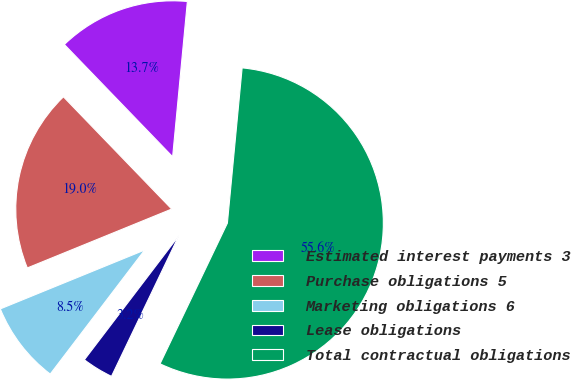Convert chart to OTSL. <chart><loc_0><loc_0><loc_500><loc_500><pie_chart><fcel>Estimated interest payments 3<fcel>Purchase obligations 5<fcel>Marketing obligations 6<fcel>Lease obligations<fcel>Total contractual obligations<nl><fcel>13.72%<fcel>18.95%<fcel>8.48%<fcel>3.25%<fcel>55.6%<nl></chart> 